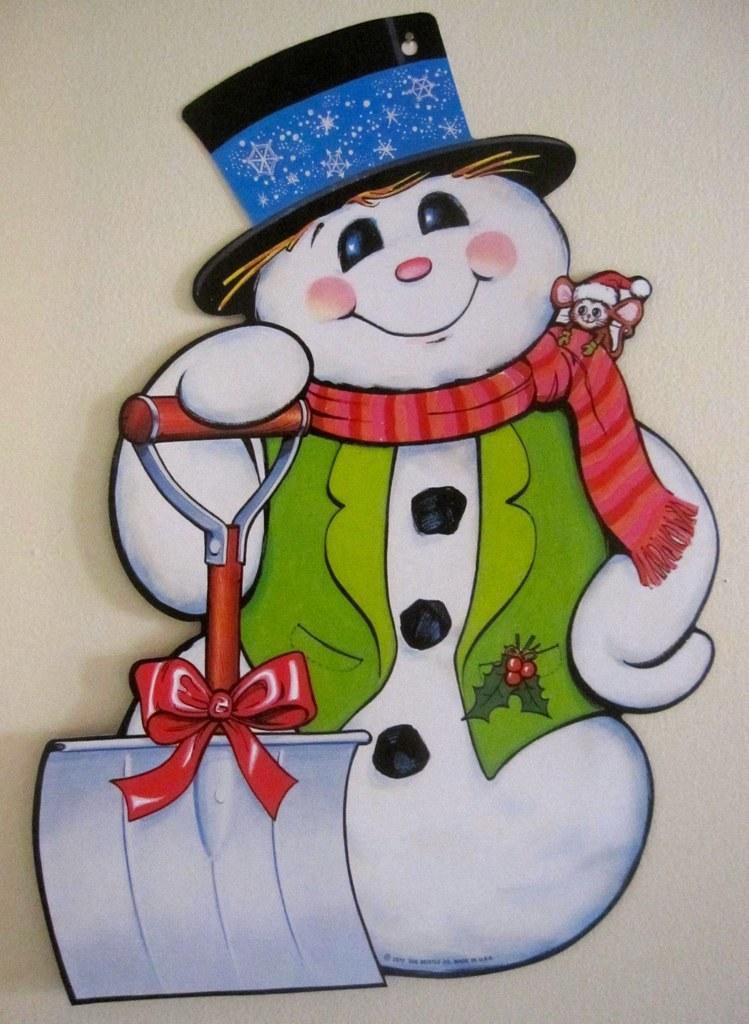In one or two sentences, can you explain what this image depicts? In this image we can see a picture of a snowman. 